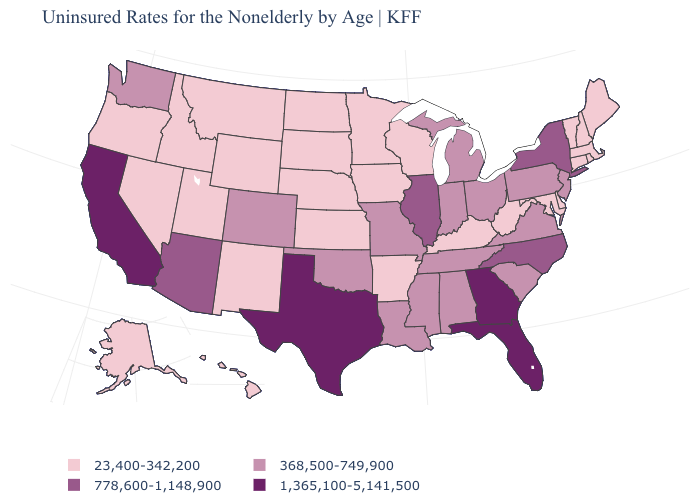Which states have the lowest value in the MidWest?
Be succinct. Iowa, Kansas, Minnesota, Nebraska, North Dakota, South Dakota, Wisconsin. Name the states that have a value in the range 1,365,100-5,141,500?
Keep it brief. California, Florida, Georgia, Texas. Which states hav the highest value in the MidWest?
Give a very brief answer. Illinois. Does Texas have the highest value in the USA?
Be succinct. Yes. Name the states that have a value in the range 778,600-1,148,900?
Quick response, please. Arizona, Illinois, New York, North Carolina. What is the value of West Virginia?
Give a very brief answer. 23,400-342,200. What is the value of South Carolina?
Quick response, please. 368,500-749,900. Name the states that have a value in the range 1,365,100-5,141,500?
Give a very brief answer. California, Florida, Georgia, Texas. What is the lowest value in the USA?
Be succinct. 23,400-342,200. What is the lowest value in the MidWest?
Short answer required. 23,400-342,200. Name the states that have a value in the range 1,365,100-5,141,500?
Keep it brief. California, Florida, Georgia, Texas. What is the highest value in states that border Oklahoma?
Keep it brief. 1,365,100-5,141,500. Name the states that have a value in the range 1,365,100-5,141,500?
Be succinct. California, Florida, Georgia, Texas. Among the states that border Minnesota , which have the highest value?
Quick response, please. Iowa, North Dakota, South Dakota, Wisconsin. 